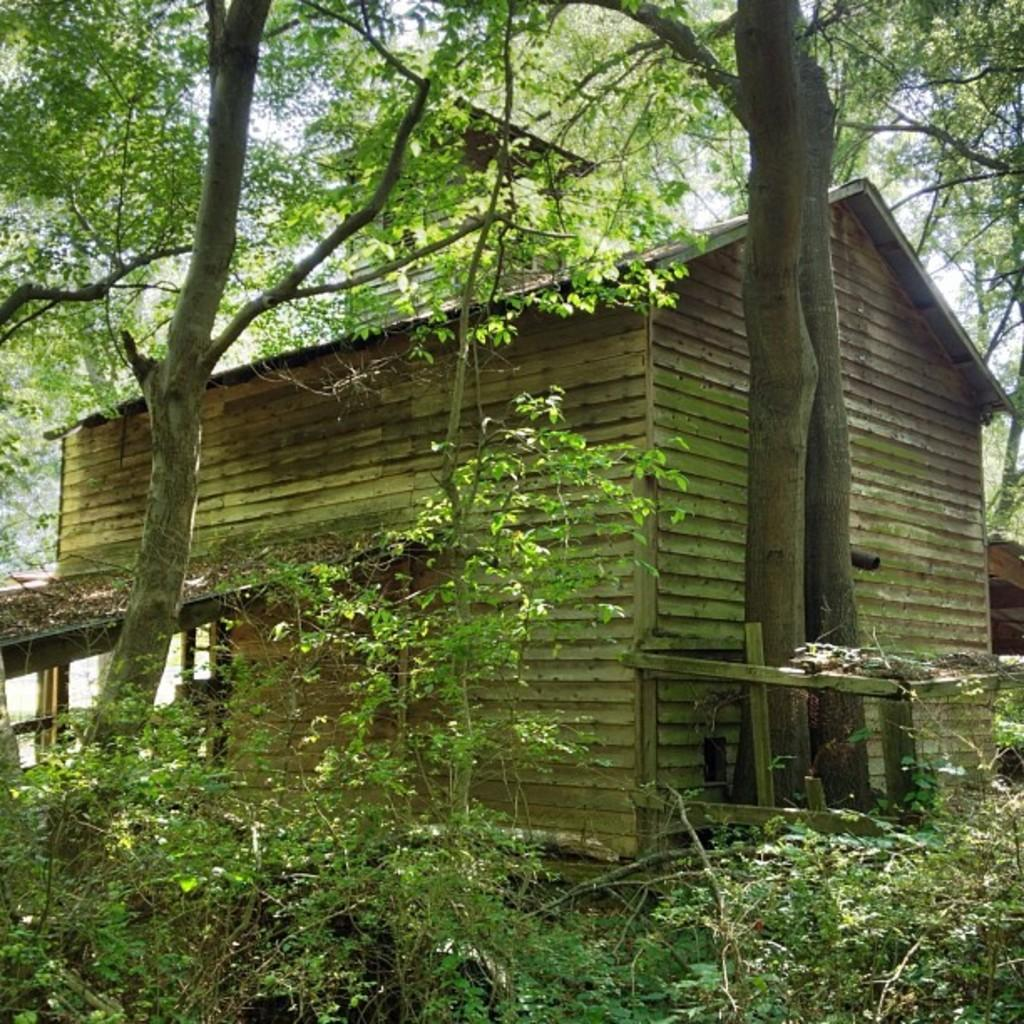What type of vegetation can be seen in the image? There are plants and trees in the image. What kind of structure is present in the image? There is a wooden house in the image. What is the price of the crook in the image? There is no crook present in the image, so it is not possible to determine its price. 